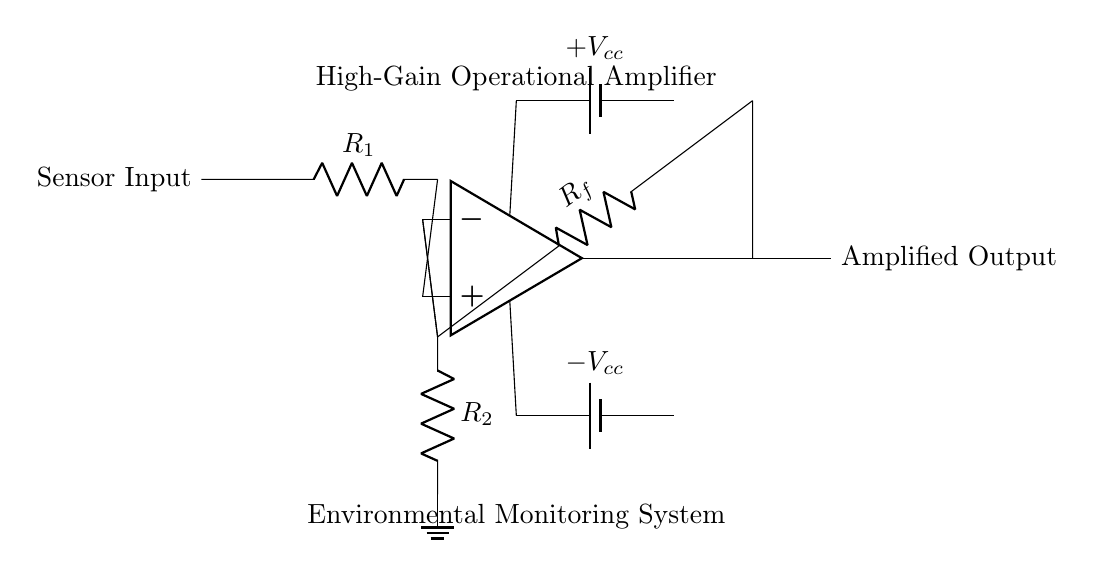What type of amplifier is used in the circuit? The circuit uses a high-gain operational amplifier, which is indicated by the label and function of the op amp symbol within the circuit.
Answer: high-gain operational amplifier What is the purpose of resistor R1? Resistor R1 is connected to the sensor input, functioning as a part of the input circuit which helps to set the gain of the amplifier and limits the current into the op amp.
Answer: set gain and limit current What is the configuration of the feedback resistor Rf? Resistor Rf is connected from the output of the operational amplifier to the negative input, creating a feedback loop that helps determine the gain of the amplifier.
Answer: feedback loop configuration What happens to the signal when it is amplified? The input signal from the sensor is increased in amplitude when passing through the operational amplifier, resulting in an amplified output voltage.
Answer: signal increases in amplitude What are the power supply voltages indicated in the circuit? The circuit includes a positive voltage supply labeled as Vcc and a negative voltage supply labeled as negative Vcc, providing necessary power for the operational amplifier to function.
Answer: Vcc and -Vcc How does resistor R2 affect the circuit? Resistor R2, connected to the negative input and ground, can influence the input impedance and affect the overall gain and stability of the amplifier.
Answer: influences gain and stability What is the expected output of the circuit? The expected output is the amplified version of the original sensor input signal, reflecting the changes in the environment being monitored.
Answer: amplified sensor input signal 